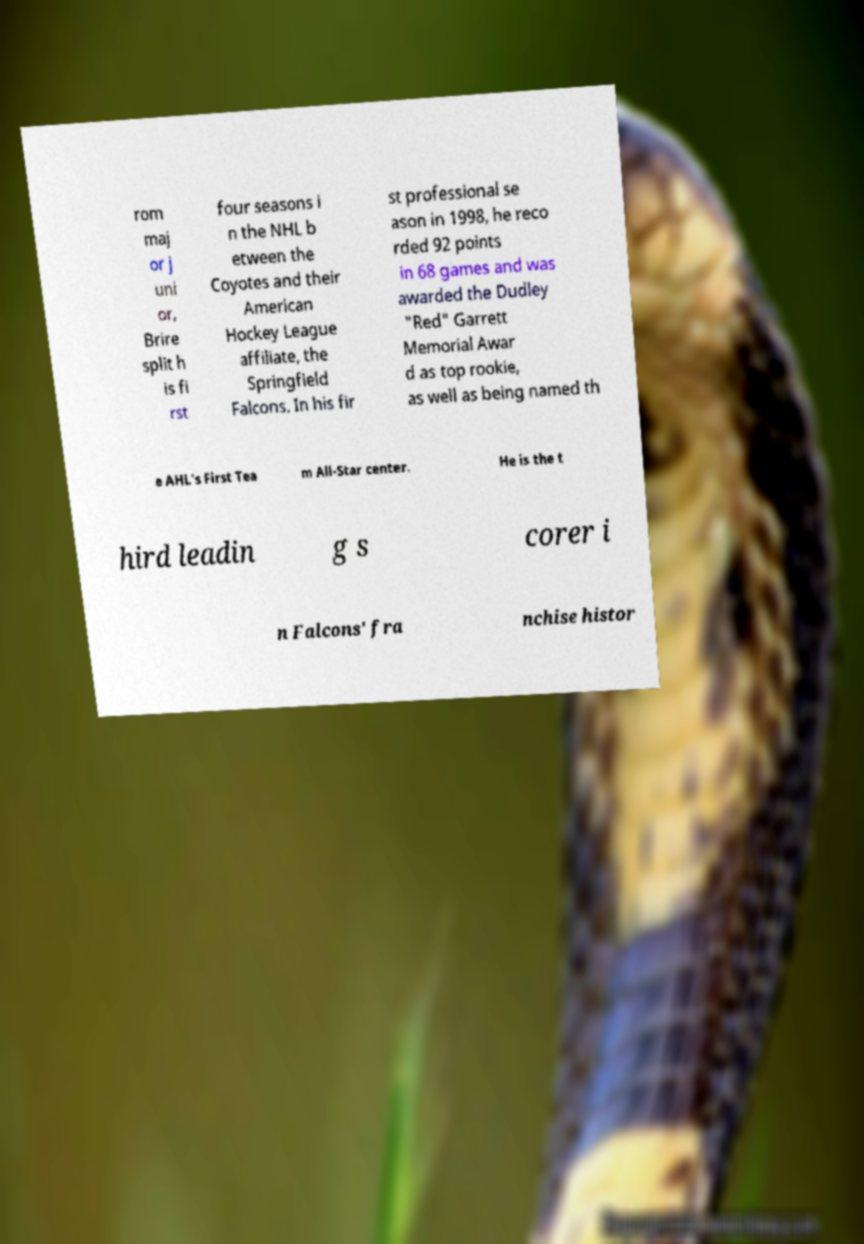There's text embedded in this image that I need extracted. Can you transcribe it verbatim? rom maj or j uni or, Brire split h is fi rst four seasons i n the NHL b etween the Coyotes and their American Hockey League affiliate, the Springfield Falcons. In his fir st professional se ason in 1998, he reco rded 92 points in 68 games and was awarded the Dudley "Red" Garrett Memorial Awar d as top rookie, as well as being named th e AHL's First Tea m All-Star center. He is the t hird leadin g s corer i n Falcons' fra nchise histor 